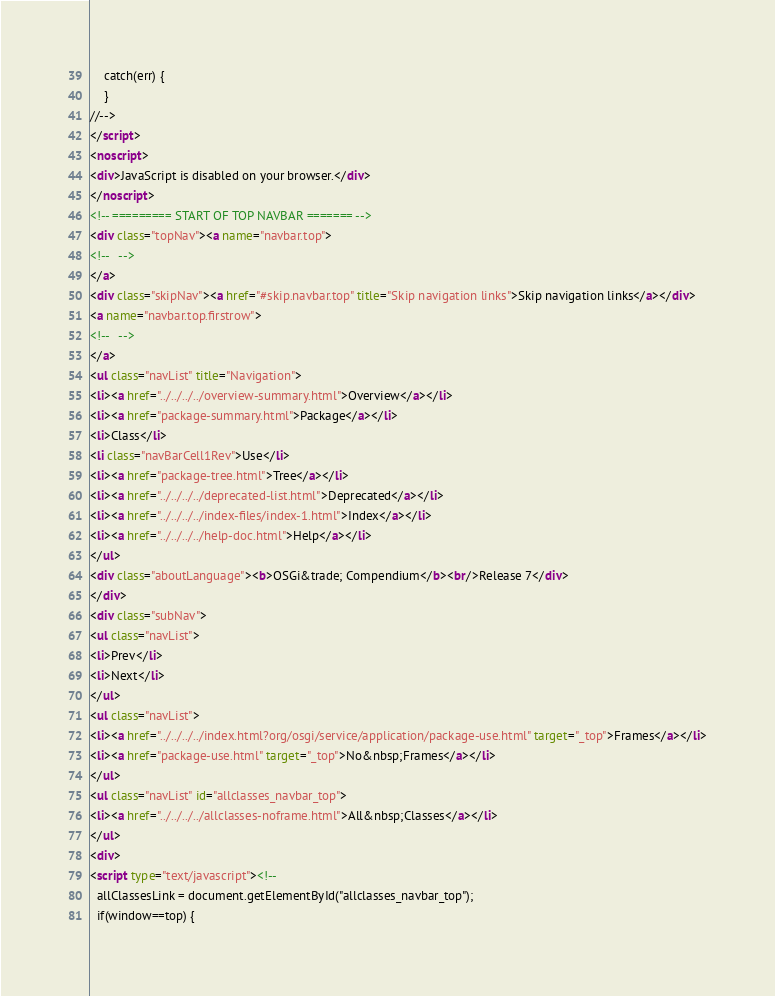Convert code to text. <code><loc_0><loc_0><loc_500><loc_500><_HTML_>    catch(err) {
    }
//-->
</script>
<noscript>
<div>JavaScript is disabled on your browser.</div>
</noscript>
<!-- ========= START OF TOP NAVBAR ======= -->
<div class="topNav"><a name="navbar.top">
<!--   -->
</a>
<div class="skipNav"><a href="#skip.navbar.top" title="Skip navigation links">Skip navigation links</a></div>
<a name="navbar.top.firstrow">
<!--   -->
</a>
<ul class="navList" title="Navigation">
<li><a href="../../../../overview-summary.html">Overview</a></li>
<li><a href="package-summary.html">Package</a></li>
<li>Class</li>
<li class="navBarCell1Rev">Use</li>
<li><a href="package-tree.html">Tree</a></li>
<li><a href="../../../../deprecated-list.html">Deprecated</a></li>
<li><a href="../../../../index-files/index-1.html">Index</a></li>
<li><a href="../../../../help-doc.html">Help</a></li>
</ul>
<div class="aboutLanguage"><b>OSGi&trade; Compendium</b><br/>Release 7</div>
</div>
<div class="subNav">
<ul class="navList">
<li>Prev</li>
<li>Next</li>
</ul>
<ul class="navList">
<li><a href="../../../../index.html?org/osgi/service/application/package-use.html" target="_top">Frames</a></li>
<li><a href="package-use.html" target="_top">No&nbsp;Frames</a></li>
</ul>
<ul class="navList" id="allclasses_navbar_top">
<li><a href="../../../../allclasses-noframe.html">All&nbsp;Classes</a></li>
</ul>
<div>
<script type="text/javascript"><!--
  allClassesLink = document.getElementById("allclasses_navbar_top");
  if(window==top) {</code> 